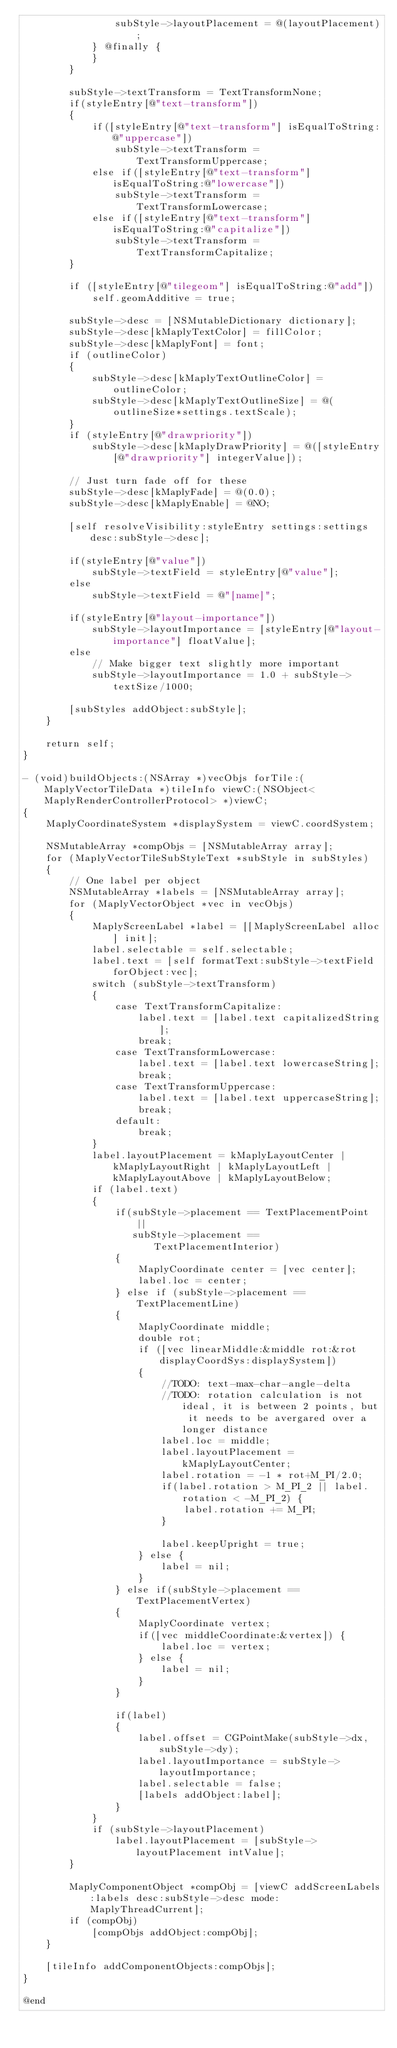<code> <loc_0><loc_0><loc_500><loc_500><_ObjectiveC_>                subStyle->layoutPlacement = @(layoutPlacement);
            } @finally {
            }
        }
        
        subStyle->textTransform = TextTransformNone;
        if(styleEntry[@"text-transform"])
        {
            if([styleEntry[@"text-transform"] isEqualToString:@"uppercase"])
                subStyle->textTransform = TextTransformUppercase;
            else if([styleEntry[@"text-transform"] isEqualToString:@"lowercase"])
                subStyle->textTransform = TextTransformLowercase;
            else if([styleEntry[@"text-transform"] isEqualToString:@"capitalize"])
                subStyle->textTransform = TextTransformCapitalize;
        }
        
        if ([styleEntry[@"tilegeom"] isEqualToString:@"add"])
            self.geomAdditive = true;
        
        subStyle->desc = [NSMutableDictionary dictionary];
        subStyle->desc[kMaplyTextColor] = fillColor;
        subStyle->desc[kMaplyFont] = font;
        if (outlineColor)
        {
            subStyle->desc[kMaplyTextOutlineColor] = outlineColor;
            subStyle->desc[kMaplyTextOutlineSize] = @(outlineSize*settings.textScale);
        }
        if (styleEntry[@"drawpriority"])
            subStyle->desc[kMaplyDrawPriority] = @([styleEntry[@"drawpriority"] integerValue]);
            
        // Just turn fade off for these
        subStyle->desc[kMaplyFade] = @(0.0);
        subStyle->desc[kMaplyEnable] = @NO;

        [self resolveVisibility:styleEntry settings:settings desc:subStyle->desc];
        
        if(styleEntry[@"value"])
            subStyle->textField = styleEntry[@"value"];
        else
            subStyle->textField = @"[name]";
        
        if(styleEntry[@"layout-importance"])
            subStyle->layoutImportance = [styleEntry[@"layout-importance"] floatValue];
        else
            // Make bigger text slightly more important
            subStyle->layoutImportance = 1.0 + subStyle->textSize/1000;
            
        [subStyles addObject:subStyle];
    }
    
    return self;
}

- (void)buildObjects:(NSArray *)vecObjs forTile:(MaplyVectorTileData *)tileInfo viewC:(NSObject<MaplyRenderControllerProtocol> *)viewC;
{
    MaplyCoordinateSystem *displaySystem = viewC.coordSystem;
    
    NSMutableArray *compObjs = [NSMutableArray array];
    for (MaplyVectorTileSubStyleText *subStyle in subStyles)
    {
        // One label per object
        NSMutableArray *labels = [NSMutableArray array];
        for (MaplyVectorObject *vec in vecObjs)
        {
            MaplyScreenLabel *label = [[MaplyScreenLabel alloc] init];
            label.selectable = self.selectable;
            label.text = [self formatText:subStyle->textField forObject:vec];
            switch (subStyle->textTransform)
            {
                case TextTransformCapitalize:
                    label.text = [label.text capitalizedString];
                    break;
                case TextTransformLowercase:
                    label.text = [label.text lowercaseString];
                    break;
                case TextTransformUppercase:
                    label.text = [label.text uppercaseString];
                    break;
                default:
                    break;
            }
            label.layoutPlacement = kMaplyLayoutCenter | kMaplyLayoutRight | kMaplyLayoutLeft | kMaplyLayoutAbove | kMaplyLayoutBelow;
            if (label.text)
            {
                if(subStyle->placement == TextPlacementPoint ||
                   subStyle->placement == TextPlacementInterior)
                {
                    MaplyCoordinate center = [vec center];
                    label.loc = center;
                } else if (subStyle->placement == TextPlacementLine)
                {
                    MaplyCoordinate middle;
                    double rot;
                    if ([vec linearMiddle:&middle rot:&rot displayCoordSys:displaySystem])
                    {
                        //TODO: text-max-char-angle-delta
                        //TODO: rotation calculation is not ideal, it is between 2 points, but it needs to be avergared over a longer distance
                        label.loc = middle;
                        label.layoutPlacement = kMaplyLayoutCenter;
                        label.rotation = -1 * rot+M_PI/2.0;
                        if(label.rotation > M_PI_2 || label.rotation < -M_PI_2) {
                            label.rotation += M_PI;
                        }

                        label.keepUpright = true;
                    } else {
                        label = nil;
                    }
                } else if(subStyle->placement == TextPlacementVertex)
                {
                    MaplyCoordinate vertex;
                    if([vec middleCoordinate:&vertex]) {
                        label.loc = vertex;
                    } else {
                        label = nil;
                    }
                }

                if(label)
                {
                    label.offset = CGPointMake(subStyle->dx, subStyle->dy);
                    label.layoutImportance = subStyle->layoutImportance;
                    label.selectable = false;
                    [labels addObject:label];
                }
            }
            if (subStyle->layoutPlacement)
                label.layoutPlacement = [subStyle->layoutPlacement intValue];
        }

        MaplyComponentObject *compObj = [viewC addScreenLabels:labels desc:subStyle->desc mode:MaplyThreadCurrent];
        if (compObj)
            [compObjs addObject:compObj];
    }
    
    [tileInfo addComponentObjects:compObjs];
}

@end
</code> 